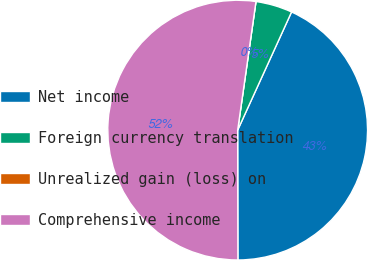Convert chart. <chart><loc_0><loc_0><loc_500><loc_500><pie_chart><fcel>Net income<fcel>Foreign currency translation<fcel>Unrealized gain (loss) on<fcel>Comprehensive income<nl><fcel>43.16%<fcel>4.56%<fcel>0.0%<fcel>52.28%<nl></chart> 